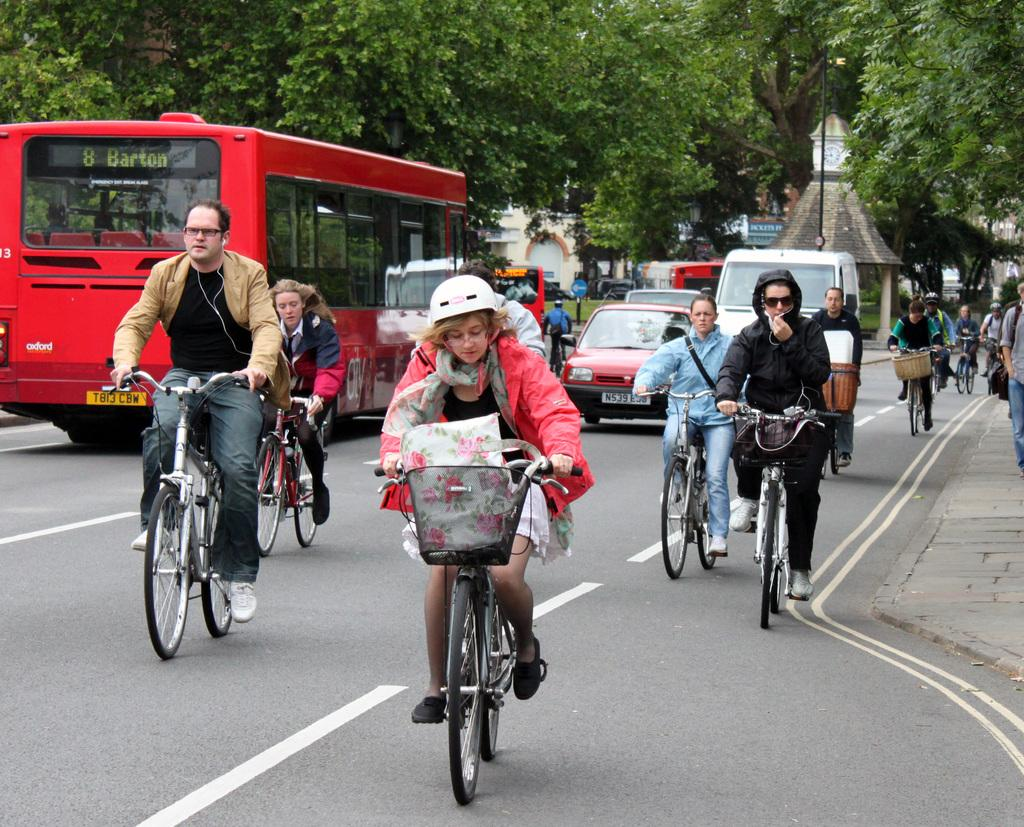What are the people in the image doing? The people in the image are riding bicycles. What else can be seen in the image besides the people on bicycles? There are other vehicles in the image. What can be seen in the background of the image? There are trees, buildings, and a road visible in the background of the image. What type of design can be seen on the cabbage in the image? There is no cabbage present in the image. How do the people on bicycles show respect to the other vehicles in the image? The image does not depict any interactions between the people on bicycles and the other vehicles, so it is not possible to determine how they show respect. 